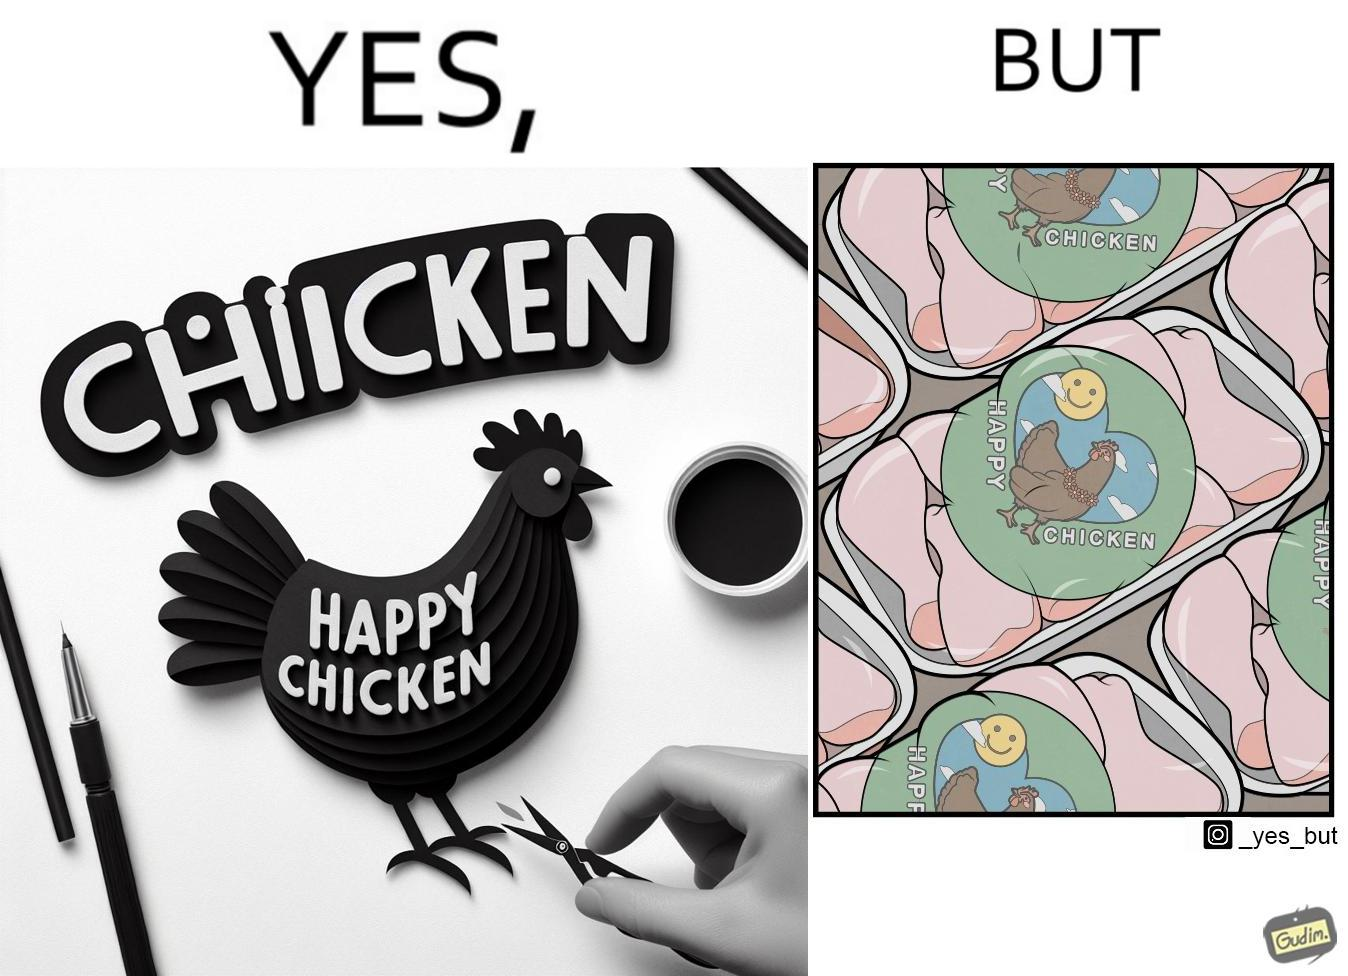Explain why this image is satirical. The image is ironic, because in the left image as in the logo it shows happy chicken but in the right image the chicken pieces are shown packed in boxes 